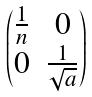<formula> <loc_0><loc_0><loc_500><loc_500>\begin{pmatrix} \frac { 1 } { n } & 0 \\ 0 & \frac { 1 } { \sqrt { a } } \end{pmatrix}</formula> 